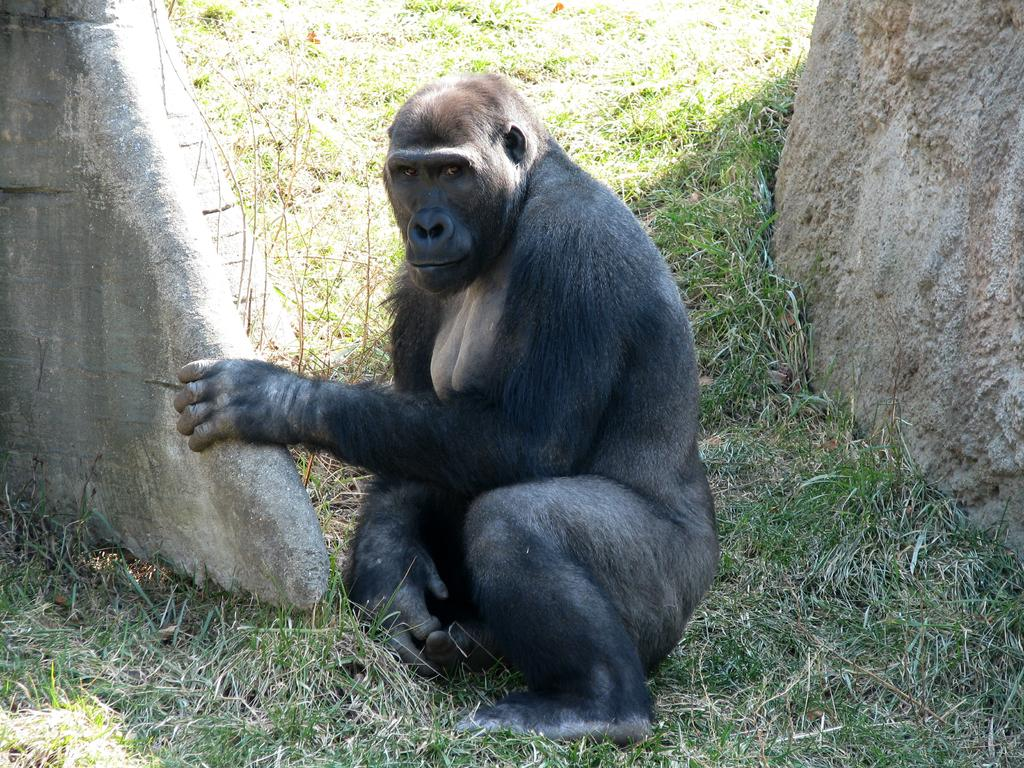What is the main subject in the center of the image? There is a chimpanzee in the center of the image. What type of vegetation is at the bottom of the image? There is grass at the bottom of the image. What type of objects are on both sides of the image? There are stones on both sides of the image. What type of breakfast is the chimpanzee eating in the image? There is no breakfast present in the image; it only features a chimpanzee, grass, and stones. 